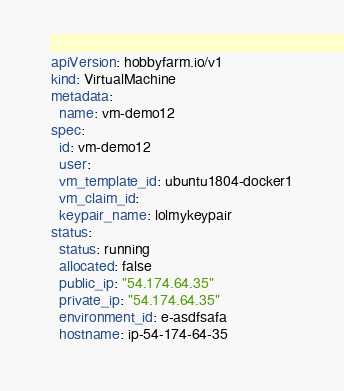Convert code to text. <code><loc_0><loc_0><loc_500><loc_500><_YAML_>apiVersion: hobbyfarm.io/v1
kind: VirtualMachine
metadata:
  name: vm-demo12
spec:
  id: vm-demo12
  user:
  vm_template_id: ubuntu1804-docker1
  vm_claim_id:
  keypair_name: lolmykeypair
status:
  status: running
  allocated: false
  public_ip: "54.174.64.35"
  private_ip: "54.174.64.35"
  environment_id: e-asdfsafa
  hostname: ip-54-174-64-35
</code> 